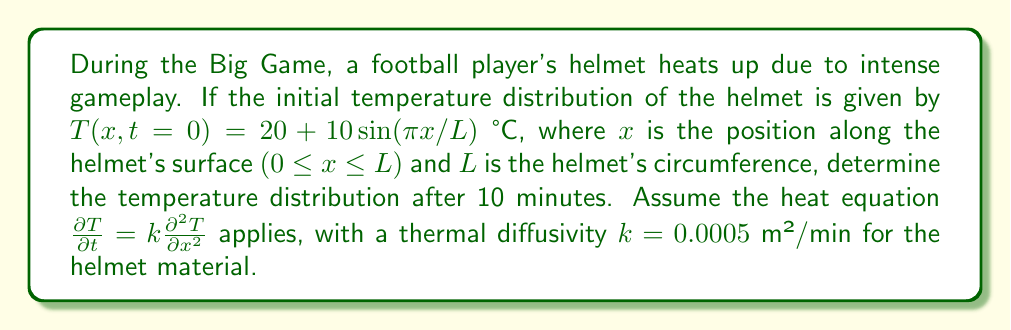Give your solution to this math problem. Let's approach this step-by-step:

1) The heat equation for this problem is:

   $$\frac{\partial T}{\partial t} = k\frac{\partial^2 T}{\partial x^2}$$

2) The initial condition is:

   $$T(x,0) = 20 + 10\sin(\pi x/L)$$

3) We can solve this using separation of variables. Let $T(x,t) = X(x)G(t)$

4) Substituting into the heat equation:

   $$X(x)G'(t) = kX''(x)G(t)$$

5) Dividing both sides by $kX(x)G(t)$:

   $$\frac{G'(t)}{kG(t)} = \frac{X''(x)}{X(x)} = -\lambda^2$$

6) This gives us two equations:
   
   $$G'(t) + k\lambda^2G(t) = 0$$
   $$X''(x) + \lambda^2X(x) = 0$$

7) The solution for $X(x)$ that satisfies the boundary conditions is:

   $$X(x) = \sin(\pi x/L)$$

   This gives us $\lambda = \pi/L$

8) The solution for $G(t)$ is:

   $$G(t) = e^{-k(\pi/L)^2t}$$

9) Therefore, the general solution is:

   $$T(x,t) = 20 + 10\sin(\pi x/L)e^{-k(\pi/L)^2t}$$

10) After 10 minutes, the temperature distribution is:

    $$T(x,10) = 20 + 10\sin(\pi x/L)e^{-0.0005(\pi/L)^2 * 10}$$

This is the final temperature distribution after 10 minutes of gameplay.
Answer: $T(x,10) = 20 + 10\sin(\pi x/L)e^{-0.0005(\pi/L)^2 * 10}$ °C 